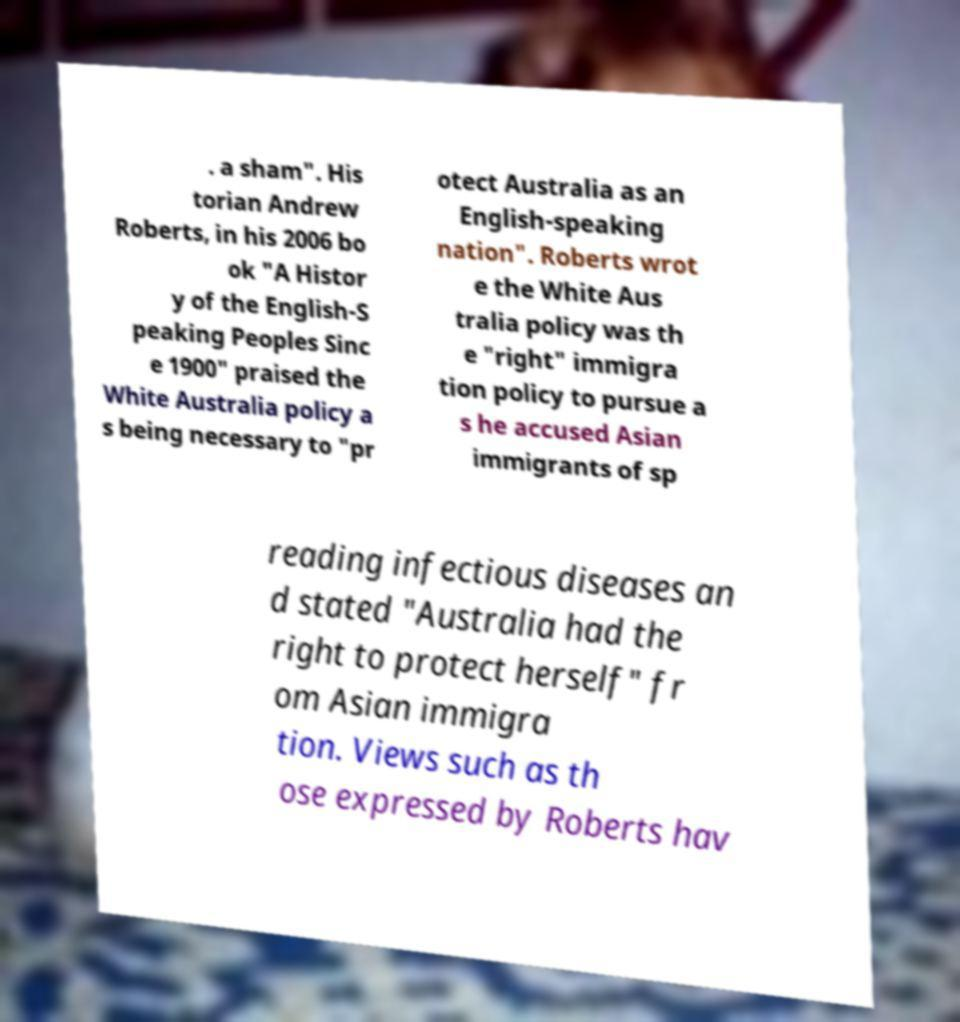Please read and relay the text visible in this image. What does it say? . a sham". His torian Andrew Roberts, in his 2006 bo ok "A Histor y of the English-S peaking Peoples Sinc e 1900" praised the White Australia policy a s being necessary to "pr otect Australia as an English-speaking nation". Roberts wrot e the White Aus tralia policy was th e "right" immigra tion policy to pursue a s he accused Asian immigrants of sp reading infectious diseases an d stated "Australia had the right to protect herself" fr om Asian immigra tion. Views such as th ose expressed by Roberts hav 